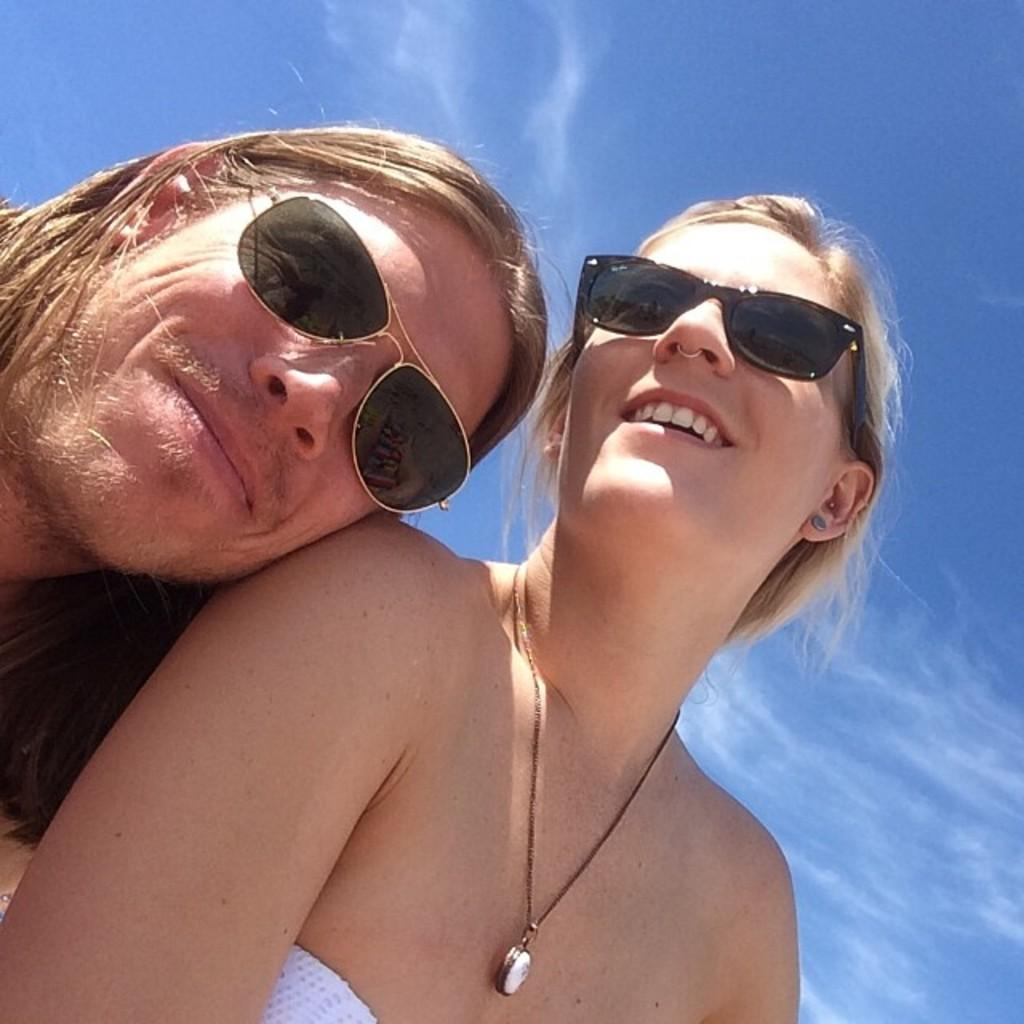Who are the people in the image? There is a man and a lady in the image. What are the people wearing in the image? Both the man and the lady are wearing glasses. What can be seen in the background of the image? The sky is visible in the background of the image. What type of screw is being used toasted at the feast in the image? There is no feast or screw present in the image. 